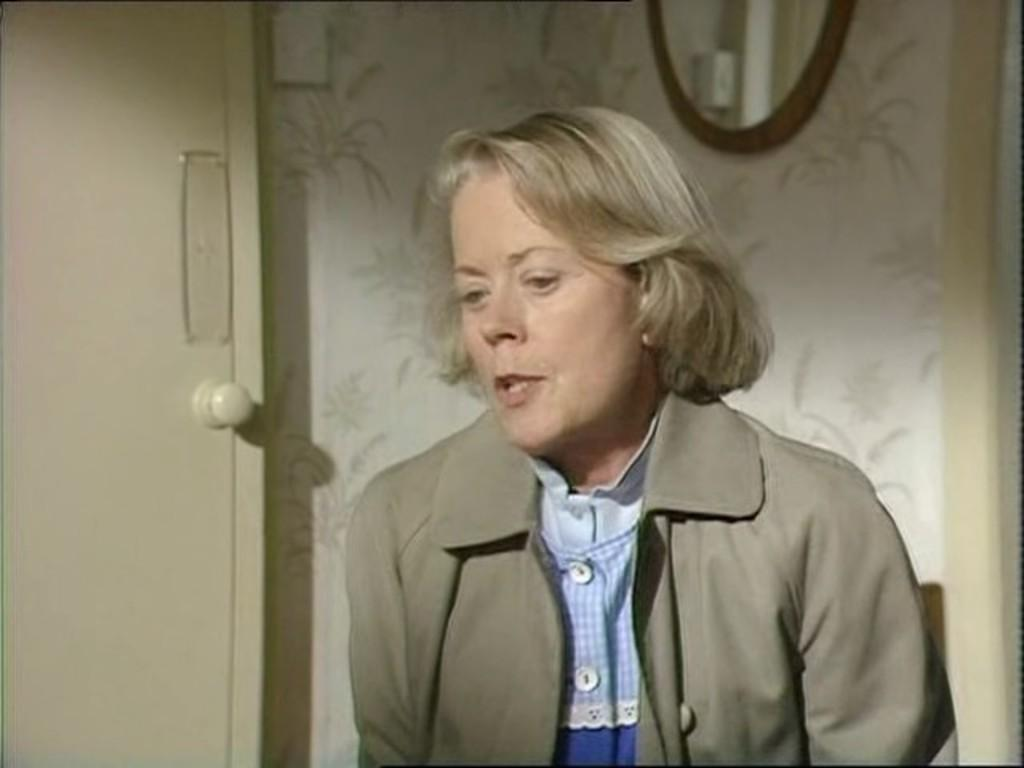Who is the main subject in the image? There is a woman in the image. What is the woman wearing? The woman is wearing a coat. What can be seen on the left side of the image? There is a door on the left side of the image. What is located at the top of the image? There is a mirror at the top of the image. What type of clouds can be seen in the image? There are no clouds visible in the image. 